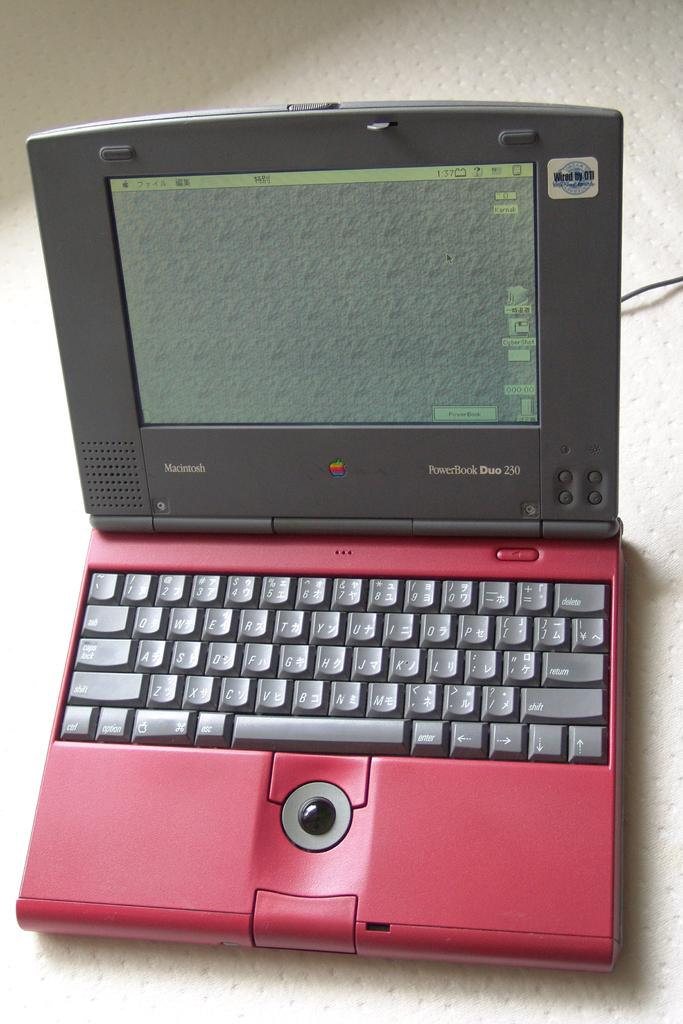<image>
Provide a brief description of the given image. Red and black laptop that is "Wired by DTI". 